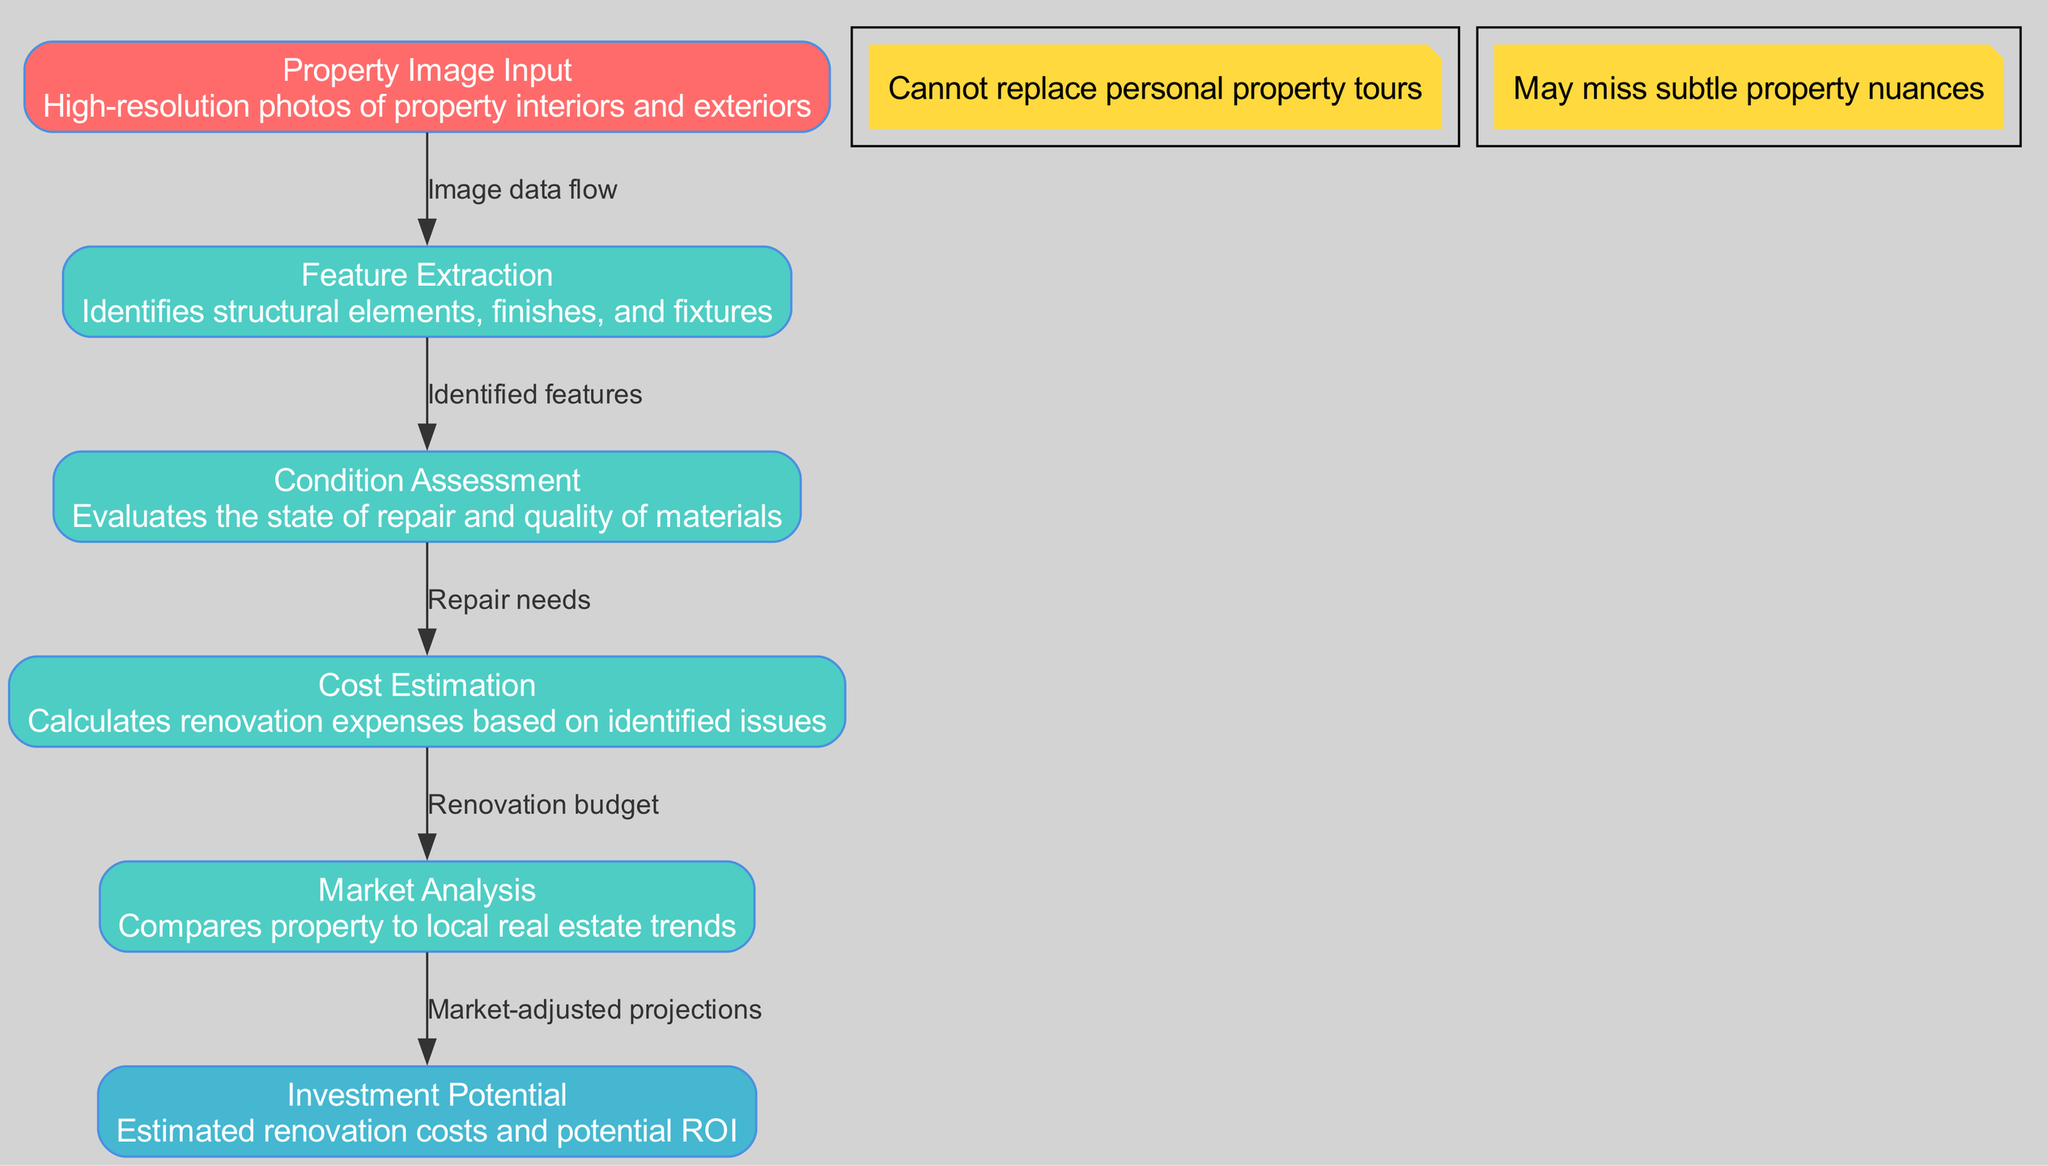What is the name of the input layer? The diagram identifies the input layer as "Property Image Input" which represents the high-resolution photos of properties.
Answer: Property Image Input How many hidden layers are there? By counting the layers listed in the diagram under "hiddenLayers", there are four distinct hidden layers shown.
Answer: Four What is the output of the network? The diagram shows the final output layer named "Investment Potential," which provides estimates for renovation costs and potential ROI.
Answer: Investment Potential What connects "Feature Extraction" to "Condition Assessment"? The connection labeled "Identified features" directly links "Feature Extraction" to "Condition Assessment" indicating the flow of information regarding identified characteristics.
Answer: Identified features Which layer assesses the state of repair? The layer responsible for evaluating the state of repair and quality of materials is called "Condition Assessment," as described in the diagram.
Answer: Condition Assessment What is the last connection's label before reaching the output? The last connection before the output layer is labeled "Market-adjusted projections," which links the "Market Analysis" to "Investment Potential."
Answer: Market-adjusted projections What does the "Cost Estimation" layer calculate? The "Cost Estimation" layer calculates renovation expenses based on identified issues, which is outlined in the description of this hidden layer.
Answer: Renovation expenses Which section commented on the uniqueness of property tours? The note positioned at the top of the diagram mentions that virtual tours cannot replace personal property tours, emphasizing the importance of physical viewings.
Answer: Cannot replace personal property tours How does the "Market Analysis" layer use information from the previous layer? The "Market Analysis" layer uses the renovation budget provided by the "Cost Estimation" layer to make market-comparative analyses for generating its outputs.
Answer: Renovation budget 